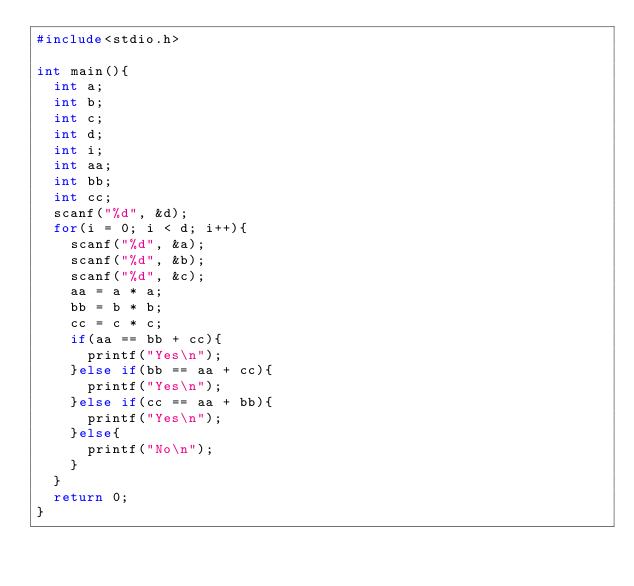<code> <loc_0><loc_0><loc_500><loc_500><_C_>#include<stdio.h>

int main(){
	int a;
	int b;
	int c;
	int d;
	int i;
	int aa;
	int bb;
	int cc;
	scanf("%d", &d);
	for(i = 0; i < d; i++){
		scanf("%d", &a);
		scanf("%d", &b);
		scanf("%d", &c);
		aa = a * a;
		bb = b * b;
		cc = c * c;
		if(aa == bb + cc){
			printf("Yes\n");
		}else if(bb == aa + cc){
			printf("Yes\n");
		}else if(cc == aa + bb){
			printf("Yes\n");
		}else{
			printf("No\n");
		}
	}
	return 0;
}</code> 